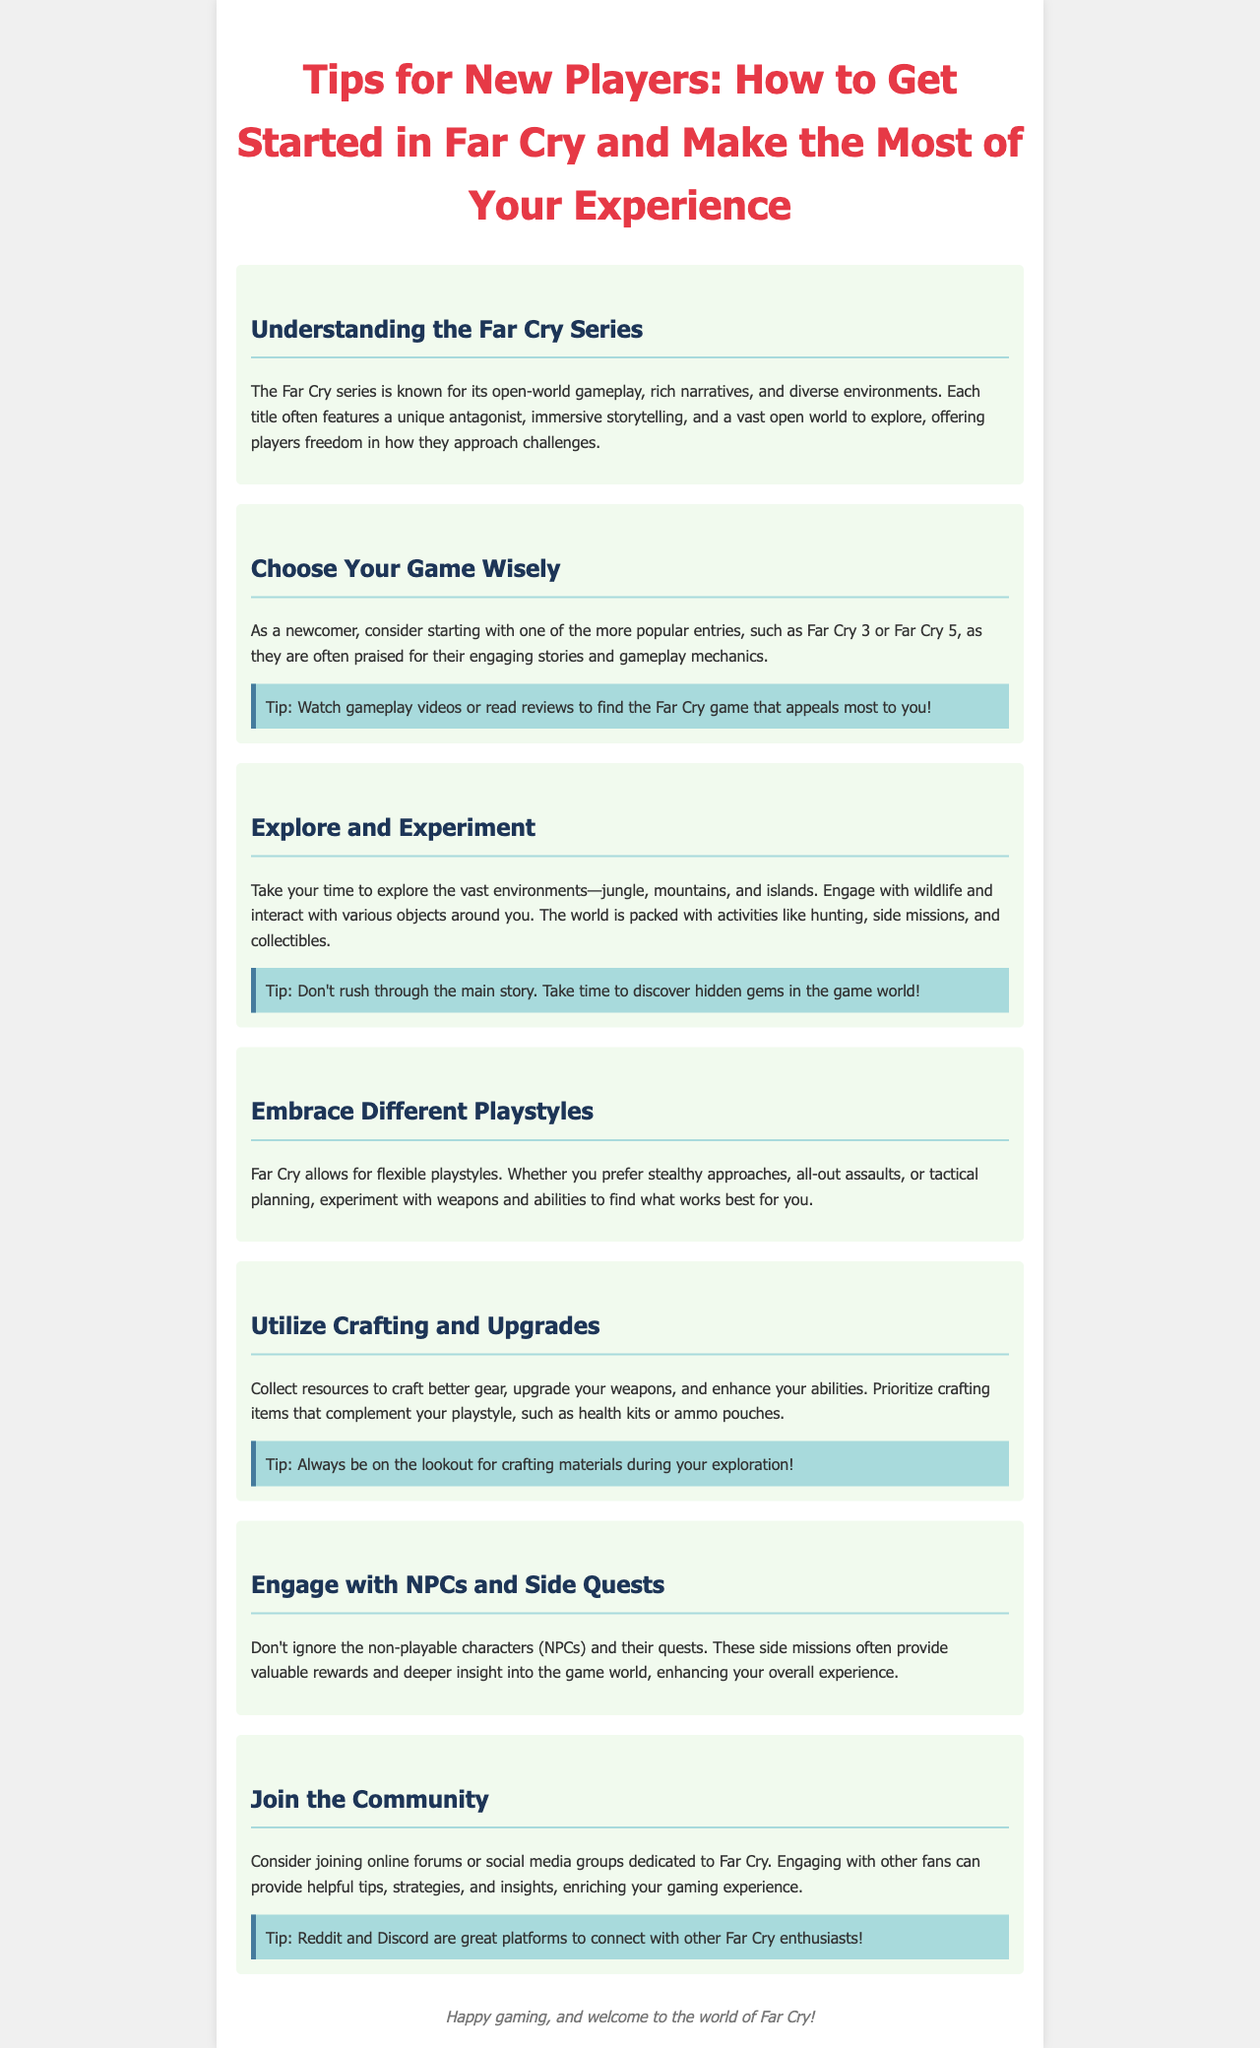what is the title of the brochure? The title is displayed prominently at the top of the document, introducing the content about tips for new players.
Answer: Tips for New Players: How to Get Started in Far Cry and Make the Most of Your Experience what series is the brochure about? The brochure clearly states that it is about a well-known game series in the first section, making it easy to identify the subject.
Answer: Far Cry which game entries are recommended for newcomers? The brochure suggests specific titles that newcomers can start with, particularly highlighted within the content.
Answer: Far Cry 3 or Far Cry 5 what should players prioritize crafting? The document mentions items that players should focus on crafting during their gameplay experience.
Answer: health kits or ammo pouches what type of gameplay does Far Cry allow? The brochure describes the flexibility in gameplay style that players can embrace throughout their experience.
Answer: flexible playstyles which platforms are recommended for joining the community? The brochure suggests specific online platforms for players to engage with the Far Cry community.
Answer: Reddit and Discord what is a key activity players are encouraged to do during exploration? The document emphasizes the importance of finding specific materials during the players' time exploring the game world.
Answer: crafting materials how does engaging with NPCs benefit players? The brochure explains the advantages of interacting with NPCs and the rewards associated with these interactions.
Answer: valuable rewards and deeper insight into the game world 